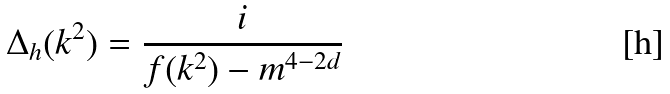<formula> <loc_0><loc_0><loc_500><loc_500>\Delta _ { h } ( k ^ { 2 } ) = \frac { i } { f ( k ^ { 2 } ) - m ^ { 4 - 2 d } }</formula> 